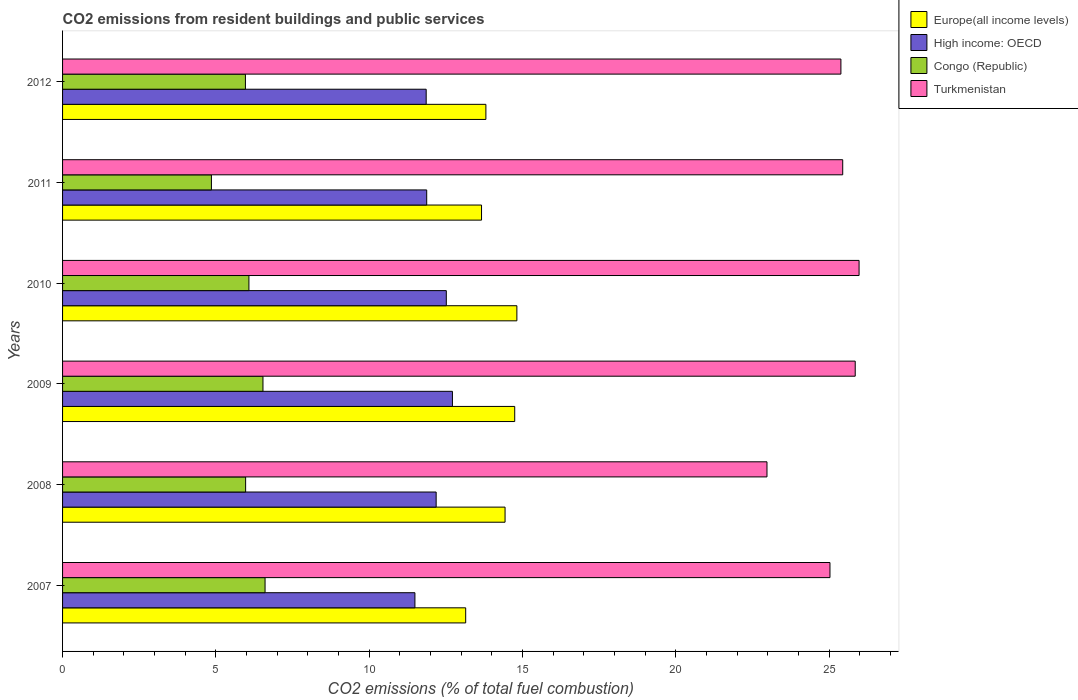How many bars are there on the 2nd tick from the top?
Your answer should be compact. 4. How many bars are there on the 2nd tick from the bottom?
Provide a succinct answer. 4. What is the total CO2 emitted in Turkmenistan in 2008?
Your answer should be very brief. 22.97. Across all years, what is the maximum total CO2 emitted in High income: OECD?
Your answer should be very brief. 12.71. Across all years, what is the minimum total CO2 emitted in Turkmenistan?
Make the answer very short. 22.97. In which year was the total CO2 emitted in Turkmenistan maximum?
Provide a short and direct response. 2010. What is the total total CO2 emitted in Congo (Republic) in the graph?
Offer a very short reply. 36. What is the difference between the total CO2 emitted in High income: OECD in 2011 and that in 2012?
Your answer should be compact. 0.02. What is the difference between the total CO2 emitted in Europe(all income levels) in 2010 and the total CO2 emitted in High income: OECD in 2009?
Your answer should be very brief. 2.1. What is the average total CO2 emitted in Turkmenistan per year?
Your answer should be very brief. 25.11. In the year 2011, what is the difference between the total CO2 emitted in Europe(all income levels) and total CO2 emitted in Turkmenistan?
Give a very brief answer. -11.78. In how many years, is the total CO2 emitted in Europe(all income levels) greater than 1 ?
Make the answer very short. 6. What is the ratio of the total CO2 emitted in Turkmenistan in 2007 to that in 2009?
Your response must be concise. 0.97. Is the difference between the total CO2 emitted in Europe(all income levels) in 2008 and 2009 greater than the difference between the total CO2 emitted in Turkmenistan in 2008 and 2009?
Give a very brief answer. Yes. What is the difference between the highest and the second highest total CO2 emitted in Congo (Republic)?
Ensure brevity in your answer.  0.07. What is the difference between the highest and the lowest total CO2 emitted in Turkmenistan?
Ensure brevity in your answer.  3. Is the sum of the total CO2 emitted in Turkmenistan in 2009 and 2011 greater than the maximum total CO2 emitted in Europe(all income levels) across all years?
Your answer should be compact. Yes. What does the 3rd bar from the top in 2007 represents?
Provide a succinct answer. High income: OECD. What does the 1st bar from the bottom in 2009 represents?
Offer a very short reply. Europe(all income levels). Are the values on the major ticks of X-axis written in scientific E-notation?
Provide a short and direct response. No. Does the graph contain any zero values?
Your answer should be compact. No. Does the graph contain grids?
Your answer should be very brief. No. How are the legend labels stacked?
Offer a terse response. Vertical. What is the title of the graph?
Give a very brief answer. CO2 emissions from resident buildings and public services. Does "Heavily indebted poor countries" appear as one of the legend labels in the graph?
Give a very brief answer. No. What is the label or title of the X-axis?
Your answer should be compact. CO2 emissions (% of total fuel combustion). What is the label or title of the Y-axis?
Your response must be concise. Years. What is the CO2 emissions (% of total fuel combustion) in Europe(all income levels) in 2007?
Give a very brief answer. 13.15. What is the CO2 emissions (% of total fuel combustion) of High income: OECD in 2007?
Make the answer very short. 11.49. What is the CO2 emissions (% of total fuel combustion) in Congo (Republic) in 2007?
Provide a succinct answer. 6.6. What is the CO2 emissions (% of total fuel combustion) of Turkmenistan in 2007?
Make the answer very short. 25.03. What is the CO2 emissions (% of total fuel combustion) of Europe(all income levels) in 2008?
Your answer should be very brief. 14.43. What is the CO2 emissions (% of total fuel combustion) in High income: OECD in 2008?
Your answer should be very brief. 12.18. What is the CO2 emissions (% of total fuel combustion) in Congo (Republic) in 2008?
Provide a short and direct response. 5.97. What is the CO2 emissions (% of total fuel combustion) of Turkmenistan in 2008?
Offer a very short reply. 22.97. What is the CO2 emissions (% of total fuel combustion) of Europe(all income levels) in 2009?
Make the answer very short. 14.75. What is the CO2 emissions (% of total fuel combustion) in High income: OECD in 2009?
Offer a very short reply. 12.71. What is the CO2 emissions (% of total fuel combustion) of Congo (Republic) in 2009?
Keep it short and to the point. 6.54. What is the CO2 emissions (% of total fuel combustion) in Turkmenistan in 2009?
Your response must be concise. 25.85. What is the CO2 emissions (% of total fuel combustion) of Europe(all income levels) in 2010?
Keep it short and to the point. 14.82. What is the CO2 emissions (% of total fuel combustion) in High income: OECD in 2010?
Your response must be concise. 12.51. What is the CO2 emissions (% of total fuel combustion) of Congo (Republic) in 2010?
Provide a short and direct response. 6.08. What is the CO2 emissions (% of total fuel combustion) in Turkmenistan in 2010?
Give a very brief answer. 25.98. What is the CO2 emissions (% of total fuel combustion) in Europe(all income levels) in 2011?
Your answer should be very brief. 13.66. What is the CO2 emissions (% of total fuel combustion) in High income: OECD in 2011?
Ensure brevity in your answer.  11.88. What is the CO2 emissions (% of total fuel combustion) in Congo (Republic) in 2011?
Ensure brevity in your answer.  4.85. What is the CO2 emissions (% of total fuel combustion) in Turkmenistan in 2011?
Provide a short and direct response. 25.44. What is the CO2 emissions (% of total fuel combustion) in Europe(all income levels) in 2012?
Provide a succinct answer. 13.81. What is the CO2 emissions (% of total fuel combustion) in High income: OECD in 2012?
Offer a terse response. 11.86. What is the CO2 emissions (% of total fuel combustion) in Congo (Republic) in 2012?
Your answer should be very brief. 5.96. What is the CO2 emissions (% of total fuel combustion) of Turkmenistan in 2012?
Provide a short and direct response. 25.38. Across all years, what is the maximum CO2 emissions (% of total fuel combustion) in Europe(all income levels)?
Your answer should be compact. 14.82. Across all years, what is the maximum CO2 emissions (% of total fuel combustion) in High income: OECD?
Make the answer very short. 12.71. Across all years, what is the maximum CO2 emissions (% of total fuel combustion) of Congo (Republic)?
Your response must be concise. 6.6. Across all years, what is the maximum CO2 emissions (% of total fuel combustion) of Turkmenistan?
Keep it short and to the point. 25.98. Across all years, what is the minimum CO2 emissions (% of total fuel combustion) in Europe(all income levels)?
Keep it short and to the point. 13.15. Across all years, what is the minimum CO2 emissions (% of total fuel combustion) in High income: OECD?
Make the answer very short. 11.49. Across all years, what is the minimum CO2 emissions (% of total fuel combustion) of Congo (Republic)?
Provide a short and direct response. 4.85. Across all years, what is the minimum CO2 emissions (% of total fuel combustion) of Turkmenistan?
Your response must be concise. 22.97. What is the total CO2 emissions (% of total fuel combustion) in Europe(all income levels) in the graph?
Offer a terse response. 84.61. What is the total CO2 emissions (% of total fuel combustion) in High income: OECD in the graph?
Offer a very short reply. 72.64. What is the total CO2 emissions (% of total fuel combustion) in Congo (Republic) in the graph?
Provide a short and direct response. 36. What is the total CO2 emissions (% of total fuel combustion) in Turkmenistan in the graph?
Offer a terse response. 150.65. What is the difference between the CO2 emissions (% of total fuel combustion) in Europe(all income levels) in 2007 and that in 2008?
Offer a very short reply. -1.28. What is the difference between the CO2 emissions (% of total fuel combustion) in High income: OECD in 2007 and that in 2008?
Your response must be concise. -0.69. What is the difference between the CO2 emissions (% of total fuel combustion) in Congo (Republic) in 2007 and that in 2008?
Your answer should be very brief. 0.63. What is the difference between the CO2 emissions (% of total fuel combustion) of Turkmenistan in 2007 and that in 2008?
Ensure brevity in your answer.  2.05. What is the difference between the CO2 emissions (% of total fuel combustion) of Europe(all income levels) in 2007 and that in 2009?
Your answer should be very brief. -1.6. What is the difference between the CO2 emissions (% of total fuel combustion) in High income: OECD in 2007 and that in 2009?
Offer a very short reply. -1.22. What is the difference between the CO2 emissions (% of total fuel combustion) of Congo (Republic) in 2007 and that in 2009?
Make the answer very short. 0.07. What is the difference between the CO2 emissions (% of total fuel combustion) in Turkmenistan in 2007 and that in 2009?
Offer a very short reply. -0.82. What is the difference between the CO2 emissions (% of total fuel combustion) in Europe(all income levels) in 2007 and that in 2010?
Offer a very short reply. -1.67. What is the difference between the CO2 emissions (% of total fuel combustion) of High income: OECD in 2007 and that in 2010?
Keep it short and to the point. -1.02. What is the difference between the CO2 emissions (% of total fuel combustion) in Congo (Republic) in 2007 and that in 2010?
Make the answer very short. 0.53. What is the difference between the CO2 emissions (% of total fuel combustion) in Turkmenistan in 2007 and that in 2010?
Ensure brevity in your answer.  -0.95. What is the difference between the CO2 emissions (% of total fuel combustion) of Europe(all income levels) in 2007 and that in 2011?
Your answer should be very brief. -0.52. What is the difference between the CO2 emissions (% of total fuel combustion) in High income: OECD in 2007 and that in 2011?
Give a very brief answer. -0.38. What is the difference between the CO2 emissions (% of total fuel combustion) of Congo (Republic) in 2007 and that in 2011?
Your response must be concise. 1.75. What is the difference between the CO2 emissions (% of total fuel combustion) in Turkmenistan in 2007 and that in 2011?
Keep it short and to the point. -0.42. What is the difference between the CO2 emissions (% of total fuel combustion) of Europe(all income levels) in 2007 and that in 2012?
Make the answer very short. -0.66. What is the difference between the CO2 emissions (% of total fuel combustion) of High income: OECD in 2007 and that in 2012?
Make the answer very short. -0.37. What is the difference between the CO2 emissions (% of total fuel combustion) of Congo (Republic) in 2007 and that in 2012?
Offer a very short reply. 0.64. What is the difference between the CO2 emissions (% of total fuel combustion) in Turkmenistan in 2007 and that in 2012?
Your answer should be very brief. -0.36. What is the difference between the CO2 emissions (% of total fuel combustion) of Europe(all income levels) in 2008 and that in 2009?
Keep it short and to the point. -0.32. What is the difference between the CO2 emissions (% of total fuel combustion) in High income: OECD in 2008 and that in 2009?
Offer a very short reply. -0.53. What is the difference between the CO2 emissions (% of total fuel combustion) in Congo (Republic) in 2008 and that in 2009?
Your answer should be very brief. -0.57. What is the difference between the CO2 emissions (% of total fuel combustion) of Turkmenistan in 2008 and that in 2009?
Offer a terse response. -2.88. What is the difference between the CO2 emissions (% of total fuel combustion) of Europe(all income levels) in 2008 and that in 2010?
Keep it short and to the point. -0.39. What is the difference between the CO2 emissions (% of total fuel combustion) of High income: OECD in 2008 and that in 2010?
Your response must be concise. -0.33. What is the difference between the CO2 emissions (% of total fuel combustion) of Congo (Republic) in 2008 and that in 2010?
Offer a terse response. -0.11. What is the difference between the CO2 emissions (% of total fuel combustion) of Turkmenistan in 2008 and that in 2010?
Offer a terse response. -3. What is the difference between the CO2 emissions (% of total fuel combustion) in Europe(all income levels) in 2008 and that in 2011?
Your answer should be compact. 0.77. What is the difference between the CO2 emissions (% of total fuel combustion) in High income: OECD in 2008 and that in 2011?
Your answer should be compact. 0.31. What is the difference between the CO2 emissions (% of total fuel combustion) of Congo (Republic) in 2008 and that in 2011?
Your answer should be compact. 1.12. What is the difference between the CO2 emissions (% of total fuel combustion) of Turkmenistan in 2008 and that in 2011?
Offer a very short reply. -2.47. What is the difference between the CO2 emissions (% of total fuel combustion) in Europe(all income levels) in 2008 and that in 2012?
Offer a terse response. 0.63. What is the difference between the CO2 emissions (% of total fuel combustion) of High income: OECD in 2008 and that in 2012?
Make the answer very short. 0.33. What is the difference between the CO2 emissions (% of total fuel combustion) of Congo (Republic) in 2008 and that in 2012?
Your answer should be compact. 0.01. What is the difference between the CO2 emissions (% of total fuel combustion) in Turkmenistan in 2008 and that in 2012?
Give a very brief answer. -2.41. What is the difference between the CO2 emissions (% of total fuel combustion) in Europe(all income levels) in 2009 and that in 2010?
Give a very brief answer. -0.07. What is the difference between the CO2 emissions (% of total fuel combustion) in High income: OECD in 2009 and that in 2010?
Your response must be concise. 0.2. What is the difference between the CO2 emissions (% of total fuel combustion) in Congo (Republic) in 2009 and that in 2010?
Make the answer very short. 0.46. What is the difference between the CO2 emissions (% of total fuel combustion) of Turkmenistan in 2009 and that in 2010?
Offer a very short reply. -0.13. What is the difference between the CO2 emissions (% of total fuel combustion) in Europe(all income levels) in 2009 and that in 2011?
Make the answer very short. 1.08. What is the difference between the CO2 emissions (% of total fuel combustion) in High income: OECD in 2009 and that in 2011?
Provide a succinct answer. 0.84. What is the difference between the CO2 emissions (% of total fuel combustion) of Congo (Republic) in 2009 and that in 2011?
Keep it short and to the point. 1.68. What is the difference between the CO2 emissions (% of total fuel combustion) of Turkmenistan in 2009 and that in 2011?
Provide a succinct answer. 0.41. What is the difference between the CO2 emissions (% of total fuel combustion) of Europe(all income levels) in 2009 and that in 2012?
Keep it short and to the point. 0.94. What is the difference between the CO2 emissions (% of total fuel combustion) of High income: OECD in 2009 and that in 2012?
Your answer should be compact. 0.86. What is the difference between the CO2 emissions (% of total fuel combustion) of Congo (Republic) in 2009 and that in 2012?
Provide a succinct answer. 0.57. What is the difference between the CO2 emissions (% of total fuel combustion) in Turkmenistan in 2009 and that in 2012?
Make the answer very short. 0.47. What is the difference between the CO2 emissions (% of total fuel combustion) in Europe(all income levels) in 2010 and that in 2011?
Your response must be concise. 1.15. What is the difference between the CO2 emissions (% of total fuel combustion) in High income: OECD in 2010 and that in 2011?
Give a very brief answer. 0.64. What is the difference between the CO2 emissions (% of total fuel combustion) in Congo (Republic) in 2010 and that in 2011?
Give a very brief answer. 1.22. What is the difference between the CO2 emissions (% of total fuel combustion) in Turkmenistan in 2010 and that in 2011?
Provide a short and direct response. 0.53. What is the difference between the CO2 emissions (% of total fuel combustion) of Europe(all income levels) in 2010 and that in 2012?
Make the answer very short. 1.01. What is the difference between the CO2 emissions (% of total fuel combustion) of High income: OECD in 2010 and that in 2012?
Give a very brief answer. 0.66. What is the difference between the CO2 emissions (% of total fuel combustion) in Congo (Republic) in 2010 and that in 2012?
Your answer should be very brief. 0.11. What is the difference between the CO2 emissions (% of total fuel combustion) in Turkmenistan in 2010 and that in 2012?
Keep it short and to the point. 0.59. What is the difference between the CO2 emissions (% of total fuel combustion) of Europe(all income levels) in 2011 and that in 2012?
Ensure brevity in your answer.  -0.14. What is the difference between the CO2 emissions (% of total fuel combustion) in High income: OECD in 2011 and that in 2012?
Make the answer very short. 0.02. What is the difference between the CO2 emissions (% of total fuel combustion) of Congo (Republic) in 2011 and that in 2012?
Offer a very short reply. -1.11. What is the difference between the CO2 emissions (% of total fuel combustion) of Turkmenistan in 2011 and that in 2012?
Offer a terse response. 0.06. What is the difference between the CO2 emissions (% of total fuel combustion) of Europe(all income levels) in 2007 and the CO2 emissions (% of total fuel combustion) of High income: OECD in 2008?
Give a very brief answer. 0.96. What is the difference between the CO2 emissions (% of total fuel combustion) of Europe(all income levels) in 2007 and the CO2 emissions (% of total fuel combustion) of Congo (Republic) in 2008?
Offer a very short reply. 7.18. What is the difference between the CO2 emissions (% of total fuel combustion) of Europe(all income levels) in 2007 and the CO2 emissions (% of total fuel combustion) of Turkmenistan in 2008?
Provide a short and direct response. -9.83. What is the difference between the CO2 emissions (% of total fuel combustion) of High income: OECD in 2007 and the CO2 emissions (% of total fuel combustion) of Congo (Republic) in 2008?
Ensure brevity in your answer.  5.52. What is the difference between the CO2 emissions (% of total fuel combustion) of High income: OECD in 2007 and the CO2 emissions (% of total fuel combustion) of Turkmenistan in 2008?
Provide a short and direct response. -11.48. What is the difference between the CO2 emissions (% of total fuel combustion) in Congo (Republic) in 2007 and the CO2 emissions (% of total fuel combustion) in Turkmenistan in 2008?
Keep it short and to the point. -16.37. What is the difference between the CO2 emissions (% of total fuel combustion) of Europe(all income levels) in 2007 and the CO2 emissions (% of total fuel combustion) of High income: OECD in 2009?
Give a very brief answer. 0.43. What is the difference between the CO2 emissions (% of total fuel combustion) in Europe(all income levels) in 2007 and the CO2 emissions (% of total fuel combustion) in Congo (Republic) in 2009?
Offer a very short reply. 6.61. What is the difference between the CO2 emissions (% of total fuel combustion) in Europe(all income levels) in 2007 and the CO2 emissions (% of total fuel combustion) in Turkmenistan in 2009?
Make the answer very short. -12.7. What is the difference between the CO2 emissions (% of total fuel combustion) in High income: OECD in 2007 and the CO2 emissions (% of total fuel combustion) in Congo (Republic) in 2009?
Make the answer very short. 4.96. What is the difference between the CO2 emissions (% of total fuel combustion) of High income: OECD in 2007 and the CO2 emissions (% of total fuel combustion) of Turkmenistan in 2009?
Your answer should be very brief. -14.36. What is the difference between the CO2 emissions (% of total fuel combustion) in Congo (Republic) in 2007 and the CO2 emissions (% of total fuel combustion) in Turkmenistan in 2009?
Keep it short and to the point. -19.25. What is the difference between the CO2 emissions (% of total fuel combustion) of Europe(all income levels) in 2007 and the CO2 emissions (% of total fuel combustion) of High income: OECD in 2010?
Provide a succinct answer. 0.63. What is the difference between the CO2 emissions (% of total fuel combustion) in Europe(all income levels) in 2007 and the CO2 emissions (% of total fuel combustion) in Congo (Republic) in 2010?
Keep it short and to the point. 7.07. What is the difference between the CO2 emissions (% of total fuel combustion) in Europe(all income levels) in 2007 and the CO2 emissions (% of total fuel combustion) in Turkmenistan in 2010?
Offer a very short reply. -12.83. What is the difference between the CO2 emissions (% of total fuel combustion) in High income: OECD in 2007 and the CO2 emissions (% of total fuel combustion) in Congo (Republic) in 2010?
Your response must be concise. 5.41. What is the difference between the CO2 emissions (% of total fuel combustion) in High income: OECD in 2007 and the CO2 emissions (% of total fuel combustion) in Turkmenistan in 2010?
Make the answer very short. -14.49. What is the difference between the CO2 emissions (% of total fuel combustion) of Congo (Republic) in 2007 and the CO2 emissions (% of total fuel combustion) of Turkmenistan in 2010?
Offer a very short reply. -19.37. What is the difference between the CO2 emissions (% of total fuel combustion) in Europe(all income levels) in 2007 and the CO2 emissions (% of total fuel combustion) in High income: OECD in 2011?
Keep it short and to the point. 1.27. What is the difference between the CO2 emissions (% of total fuel combustion) of Europe(all income levels) in 2007 and the CO2 emissions (% of total fuel combustion) of Congo (Republic) in 2011?
Offer a very short reply. 8.29. What is the difference between the CO2 emissions (% of total fuel combustion) in Europe(all income levels) in 2007 and the CO2 emissions (% of total fuel combustion) in Turkmenistan in 2011?
Provide a short and direct response. -12.3. What is the difference between the CO2 emissions (% of total fuel combustion) of High income: OECD in 2007 and the CO2 emissions (% of total fuel combustion) of Congo (Republic) in 2011?
Make the answer very short. 6.64. What is the difference between the CO2 emissions (% of total fuel combustion) of High income: OECD in 2007 and the CO2 emissions (% of total fuel combustion) of Turkmenistan in 2011?
Offer a terse response. -13.95. What is the difference between the CO2 emissions (% of total fuel combustion) in Congo (Republic) in 2007 and the CO2 emissions (% of total fuel combustion) in Turkmenistan in 2011?
Make the answer very short. -18.84. What is the difference between the CO2 emissions (% of total fuel combustion) of Europe(all income levels) in 2007 and the CO2 emissions (% of total fuel combustion) of High income: OECD in 2012?
Offer a very short reply. 1.29. What is the difference between the CO2 emissions (% of total fuel combustion) of Europe(all income levels) in 2007 and the CO2 emissions (% of total fuel combustion) of Congo (Republic) in 2012?
Offer a very short reply. 7.18. What is the difference between the CO2 emissions (% of total fuel combustion) of Europe(all income levels) in 2007 and the CO2 emissions (% of total fuel combustion) of Turkmenistan in 2012?
Give a very brief answer. -12.24. What is the difference between the CO2 emissions (% of total fuel combustion) in High income: OECD in 2007 and the CO2 emissions (% of total fuel combustion) in Congo (Republic) in 2012?
Offer a very short reply. 5.53. What is the difference between the CO2 emissions (% of total fuel combustion) of High income: OECD in 2007 and the CO2 emissions (% of total fuel combustion) of Turkmenistan in 2012?
Provide a short and direct response. -13.89. What is the difference between the CO2 emissions (% of total fuel combustion) in Congo (Republic) in 2007 and the CO2 emissions (% of total fuel combustion) in Turkmenistan in 2012?
Keep it short and to the point. -18.78. What is the difference between the CO2 emissions (% of total fuel combustion) of Europe(all income levels) in 2008 and the CO2 emissions (% of total fuel combustion) of High income: OECD in 2009?
Offer a very short reply. 1.72. What is the difference between the CO2 emissions (% of total fuel combustion) of Europe(all income levels) in 2008 and the CO2 emissions (% of total fuel combustion) of Congo (Republic) in 2009?
Provide a succinct answer. 7.89. What is the difference between the CO2 emissions (% of total fuel combustion) in Europe(all income levels) in 2008 and the CO2 emissions (% of total fuel combustion) in Turkmenistan in 2009?
Make the answer very short. -11.42. What is the difference between the CO2 emissions (% of total fuel combustion) of High income: OECD in 2008 and the CO2 emissions (% of total fuel combustion) of Congo (Republic) in 2009?
Your answer should be very brief. 5.65. What is the difference between the CO2 emissions (% of total fuel combustion) in High income: OECD in 2008 and the CO2 emissions (% of total fuel combustion) in Turkmenistan in 2009?
Ensure brevity in your answer.  -13.67. What is the difference between the CO2 emissions (% of total fuel combustion) of Congo (Republic) in 2008 and the CO2 emissions (% of total fuel combustion) of Turkmenistan in 2009?
Your answer should be very brief. -19.88. What is the difference between the CO2 emissions (% of total fuel combustion) in Europe(all income levels) in 2008 and the CO2 emissions (% of total fuel combustion) in High income: OECD in 2010?
Offer a very short reply. 1.92. What is the difference between the CO2 emissions (% of total fuel combustion) of Europe(all income levels) in 2008 and the CO2 emissions (% of total fuel combustion) of Congo (Republic) in 2010?
Provide a succinct answer. 8.35. What is the difference between the CO2 emissions (% of total fuel combustion) in Europe(all income levels) in 2008 and the CO2 emissions (% of total fuel combustion) in Turkmenistan in 2010?
Offer a terse response. -11.55. What is the difference between the CO2 emissions (% of total fuel combustion) of High income: OECD in 2008 and the CO2 emissions (% of total fuel combustion) of Congo (Republic) in 2010?
Keep it short and to the point. 6.11. What is the difference between the CO2 emissions (% of total fuel combustion) of High income: OECD in 2008 and the CO2 emissions (% of total fuel combustion) of Turkmenistan in 2010?
Offer a very short reply. -13.79. What is the difference between the CO2 emissions (% of total fuel combustion) in Congo (Republic) in 2008 and the CO2 emissions (% of total fuel combustion) in Turkmenistan in 2010?
Keep it short and to the point. -20.01. What is the difference between the CO2 emissions (% of total fuel combustion) of Europe(all income levels) in 2008 and the CO2 emissions (% of total fuel combustion) of High income: OECD in 2011?
Provide a succinct answer. 2.56. What is the difference between the CO2 emissions (% of total fuel combustion) of Europe(all income levels) in 2008 and the CO2 emissions (% of total fuel combustion) of Congo (Republic) in 2011?
Ensure brevity in your answer.  9.58. What is the difference between the CO2 emissions (% of total fuel combustion) of Europe(all income levels) in 2008 and the CO2 emissions (% of total fuel combustion) of Turkmenistan in 2011?
Provide a short and direct response. -11.01. What is the difference between the CO2 emissions (% of total fuel combustion) in High income: OECD in 2008 and the CO2 emissions (% of total fuel combustion) in Congo (Republic) in 2011?
Provide a succinct answer. 7.33. What is the difference between the CO2 emissions (% of total fuel combustion) of High income: OECD in 2008 and the CO2 emissions (% of total fuel combustion) of Turkmenistan in 2011?
Ensure brevity in your answer.  -13.26. What is the difference between the CO2 emissions (% of total fuel combustion) of Congo (Republic) in 2008 and the CO2 emissions (% of total fuel combustion) of Turkmenistan in 2011?
Give a very brief answer. -19.47. What is the difference between the CO2 emissions (% of total fuel combustion) of Europe(all income levels) in 2008 and the CO2 emissions (% of total fuel combustion) of High income: OECD in 2012?
Offer a very short reply. 2.57. What is the difference between the CO2 emissions (% of total fuel combustion) in Europe(all income levels) in 2008 and the CO2 emissions (% of total fuel combustion) in Congo (Republic) in 2012?
Provide a succinct answer. 8.47. What is the difference between the CO2 emissions (% of total fuel combustion) of Europe(all income levels) in 2008 and the CO2 emissions (% of total fuel combustion) of Turkmenistan in 2012?
Keep it short and to the point. -10.95. What is the difference between the CO2 emissions (% of total fuel combustion) in High income: OECD in 2008 and the CO2 emissions (% of total fuel combustion) in Congo (Republic) in 2012?
Your response must be concise. 6.22. What is the difference between the CO2 emissions (% of total fuel combustion) of High income: OECD in 2008 and the CO2 emissions (% of total fuel combustion) of Turkmenistan in 2012?
Ensure brevity in your answer.  -13.2. What is the difference between the CO2 emissions (% of total fuel combustion) in Congo (Republic) in 2008 and the CO2 emissions (% of total fuel combustion) in Turkmenistan in 2012?
Your response must be concise. -19.41. What is the difference between the CO2 emissions (% of total fuel combustion) of Europe(all income levels) in 2009 and the CO2 emissions (% of total fuel combustion) of High income: OECD in 2010?
Offer a very short reply. 2.23. What is the difference between the CO2 emissions (% of total fuel combustion) of Europe(all income levels) in 2009 and the CO2 emissions (% of total fuel combustion) of Congo (Republic) in 2010?
Your answer should be compact. 8.67. What is the difference between the CO2 emissions (% of total fuel combustion) in Europe(all income levels) in 2009 and the CO2 emissions (% of total fuel combustion) in Turkmenistan in 2010?
Your response must be concise. -11.23. What is the difference between the CO2 emissions (% of total fuel combustion) in High income: OECD in 2009 and the CO2 emissions (% of total fuel combustion) in Congo (Republic) in 2010?
Your response must be concise. 6.64. What is the difference between the CO2 emissions (% of total fuel combustion) of High income: OECD in 2009 and the CO2 emissions (% of total fuel combustion) of Turkmenistan in 2010?
Provide a succinct answer. -13.26. What is the difference between the CO2 emissions (% of total fuel combustion) of Congo (Republic) in 2009 and the CO2 emissions (% of total fuel combustion) of Turkmenistan in 2010?
Provide a succinct answer. -19.44. What is the difference between the CO2 emissions (% of total fuel combustion) of Europe(all income levels) in 2009 and the CO2 emissions (% of total fuel combustion) of High income: OECD in 2011?
Keep it short and to the point. 2.87. What is the difference between the CO2 emissions (% of total fuel combustion) in Europe(all income levels) in 2009 and the CO2 emissions (% of total fuel combustion) in Congo (Republic) in 2011?
Provide a short and direct response. 9.89. What is the difference between the CO2 emissions (% of total fuel combustion) in Europe(all income levels) in 2009 and the CO2 emissions (% of total fuel combustion) in Turkmenistan in 2011?
Keep it short and to the point. -10.7. What is the difference between the CO2 emissions (% of total fuel combustion) of High income: OECD in 2009 and the CO2 emissions (% of total fuel combustion) of Congo (Republic) in 2011?
Your answer should be very brief. 7.86. What is the difference between the CO2 emissions (% of total fuel combustion) of High income: OECD in 2009 and the CO2 emissions (% of total fuel combustion) of Turkmenistan in 2011?
Provide a short and direct response. -12.73. What is the difference between the CO2 emissions (% of total fuel combustion) in Congo (Republic) in 2009 and the CO2 emissions (% of total fuel combustion) in Turkmenistan in 2011?
Your answer should be very brief. -18.91. What is the difference between the CO2 emissions (% of total fuel combustion) of Europe(all income levels) in 2009 and the CO2 emissions (% of total fuel combustion) of High income: OECD in 2012?
Offer a terse response. 2.89. What is the difference between the CO2 emissions (% of total fuel combustion) in Europe(all income levels) in 2009 and the CO2 emissions (% of total fuel combustion) in Congo (Republic) in 2012?
Give a very brief answer. 8.78. What is the difference between the CO2 emissions (% of total fuel combustion) in Europe(all income levels) in 2009 and the CO2 emissions (% of total fuel combustion) in Turkmenistan in 2012?
Give a very brief answer. -10.64. What is the difference between the CO2 emissions (% of total fuel combustion) in High income: OECD in 2009 and the CO2 emissions (% of total fuel combustion) in Congo (Republic) in 2012?
Offer a very short reply. 6.75. What is the difference between the CO2 emissions (% of total fuel combustion) in High income: OECD in 2009 and the CO2 emissions (% of total fuel combustion) in Turkmenistan in 2012?
Give a very brief answer. -12.67. What is the difference between the CO2 emissions (% of total fuel combustion) in Congo (Republic) in 2009 and the CO2 emissions (% of total fuel combustion) in Turkmenistan in 2012?
Give a very brief answer. -18.85. What is the difference between the CO2 emissions (% of total fuel combustion) in Europe(all income levels) in 2010 and the CO2 emissions (% of total fuel combustion) in High income: OECD in 2011?
Give a very brief answer. 2.94. What is the difference between the CO2 emissions (% of total fuel combustion) of Europe(all income levels) in 2010 and the CO2 emissions (% of total fuel combustion) of Congo (Republic) in 2011?
Offer a very short reply. 9.96. What is the difference between the CO2 emissions (% of total fuel combustion) of Europe(all income levels) in 2010 and the CO2 emissions (% of total fuel combustion) of Turkmenistan in 2011?
Offer a very short reply. -10.63. What is the difference between the CO2 emissions (% of total fuel combustion) in High income: OECD in 2010 and the CO2 emissions (% of total fuel combustion) in Congo (Republic) in 2011?
Make the answer very short. 7.66. What is the difference between the CO2 emissions (% of total fuel combustion) of High income: OECD in 2010 and the CO2 emissions (% of total fuel combustion) of Turkmenistan in 2011?
Make the answer very short. -12.93. What is the difference between the CO2 emissions (% of total fuel combustion) of Congo (Republic) in 2010 and the CO2 emissions (% of total fuel combustion) of Turkmenistan in 2011?
Your response must be concise. -19.37. What is the difference between the CO2 emissions (% of total fuel combustion) in Europe(all income levels) in 2010 and the CO2 emissions (% of total fuel combustion) in High income: OECD in 2012?
Provide a short and direct response. 2.96. What is the difference between the CO2 emissions (% of total fuel combustion) in Europe(all income levels) in 2010 and the CO2 emissions (% of total fuel combustion) in Congo (Republic) in 2012?
Your response must be concise. 8.85. What is the difference between the CO2 emissions (% of total fuel combustion) in Europe(all income levels) in 2010 and the CO2 emissions (% of total fuel combustion) in Turkmenistan in 2012?
Your response must be concise. -10.57. What is the difference between the CO2 emissions (% of total fuel combustion) in High income: OECD in 2010 and the CO2 emissions (% of total fuel combustion) in Congo (Republic) in 2012?
Provide a short and direct response. 6.55. What is the difference between the CO2 emissions (% of total fuel combustion) in High income: OECD in 2010 and the CO2 emissions (% of total fuel combustion) in Turkmenistan in 2012?
Your answer should be very brief. -12.87. What is the difference between the CO2 emissions (% of total fuel combustion) in Congo (Republic) in 2010 and the CO2 emissions (% of total fuel combustion) in Turkmenistan in 2012?
Your answer should be compact. -19.31. What is the difference between the CO2 emissions (% of total fuel combustion) in Europe(all income levels) in 2011 and the CO2 emissions (% of total fuel combustion) in High income: OECD in 2012?
Offer a very short reply. 1.8. What is the difference between the CO2 emissions (% of total fuel combustion) in Europe(all income levels) in 2011 and the CO2 emissions (% of total fuel combustion) in Congo (Republic) in 2012?
Provide a short and direct response. 7.7. What is the difference between the CO2 emissions (% of total fuel combustion) of Europe(all income levels) in 2011 and the CO2 emissions (% of total fuel combustion) of Turkmenistan in 2012?
Your answer should be compact. -11.72. What is the difference between the CO2 emissions (% of total fuel combustion) of High income: OECD in 2011 and the CO2 emissions (% of total fuel combustion) of Congo (Republic) in 2012?
Keep it short and to the point. 5.91. What is the difference between the CO2 emissions (% of total fuel combustion) of High income: OECD in 2011 and the CO2 emissions (% of total fuel combustion) of Turkmenistan in 2012?
Provide a short and direct response. -13.51. What is the difference between the CO2 emissions (% of total fuel combustion) in Congo (Republic) in 2011 and the CO2 emissions (% of total fuel combustion) in Turkmenistan in 2012?
Your answer should be very brief. -20.53. What is the average CO2 emissions (% of total fuel combustion) of Europe(all income levels) per year?
Offer a terse response. 14.1. What is the average CO2 emissions (% of total fuel combustion) in High income: OECD per year?
Your answer should be very brief. 12.11. What is the average CO2 emissions (% of total fuel combustion) of Congo (Republic) per year?
Provide a succinct answer. 6. What is the average CO2 emissions (% of total fuel combustion) of Turkmenistan per year?
Provide a short and direct response. 25.11. In the year 2007, what is the difference between the CO2 emissions (% of total fuel combustion) of Europe(all income levels) and CO2 emissions (% of total fuel combustion) of High income: OECD?
Provide a succinct answer. 1.66. In the year 2007, what is the difference between the CO2 emissions (% of total fuel combustion) in Europe(all income levels) and CO2 emissions (% of total fuel combustion) in Congo (Republic)?
Offer a very short reply. 6.54. In the year 2007, what is the difference between the CO2 emissions (% of total fuel combustion) in Europe(all income levels) and CO2 emissions (% of total fuel combustion) in Turkmenistan?
Your answer should be very brief. -11.88. In the year 2007, what is the difference between the CO2 emissions (% of total fuel combustion) in High income: OECD and CO2 emissions (% of total fuel combustion) in Congo (Republic)?
Provide a succinct answer. 4.89. In the year 2007, what is the difference between the CO2 emissions (% of total fuel combustion) of High income: OECD and CO2 emissions (% of total fuel combustion) of Turkmenistan?
Your response must be concise. -13.54. In the year 2007, what is the difference between the CO2 emissions (% of total fuel combustion) in Congo (Republic) and CO2 emissions (% of total fuel combustion) in Turkmenistan?
Ensure brevity in your answer.  -18.42. In the year 2008, what is the difference between the CO2 emissions (% of total fuel combustion) of Europe(all income levels) and CO2 emissions (% of total fuel combustion) of High income: OECD?
Ensure brevity in your answer.  2.25. In the year 2008, what is the difference between the CO2 emissions (% of total fuel combustion) of Europe(all income levels) and CO2 emissions (% of total fuel combustion) of Congo (Republic)?
Ensure brevity in your answer.  8.46. In the year 2008, what is the difference between the CO2 emissions (% of total fuel combustion) of Europe(all income levels) and CO2 emissions (% of total fuel combustion) of Turkmenistan?
Ensure brevity in your answer.  -8.54. In the year 2008, what is the difference between the CO2 emissions (% of total fuel combustion) in High income: OECD and CO2 emissions (% of total fuel combustion) in Congo (Republic)?
Provide a succinct answer. 6.21. In the year 2008, what is the difference between the CO2 emissions (% of total fuel combustion) of High income: OECD and CO2 emissions (% of total fuel combustion) of Turkmenistan?
Keep it short and to the point. -10.79. In the year 2008, what is the difference between the CO2 emissions (% of total fuel combustion) in Congo (Republic) and CO2 emissions (% of total fuel combustion) in Turkmenistan?
Your answer should be very brief. -17. In the year 2009, what is the difference between the CO2 emissions (% of total fuel combustion) of Europe(all income levels) and CO2 emissions (% of total fuel combustion) of High income: OECD?
Provide a short and direct response. 2.03. In the year 2009, what is the difference between the CO2 emissions (% of total fuel combustion) in Europe(all income levels) and CO2 emissions (% of total fuel combustion) in Congo (Republic)?
Make the answer very short. 8.21. In the year 2009, what is the difference between the CO2 emissions (% of total fuel combustion) of Europe(all income levels) and CO2 emissions (% of total fuel combustion) of Turkmenistan?
Provide a short and direct response. -11.1. In the year 2009, what is the difference between the CO2 emissions (% of total fuel combustion) in High income: OECD and CO2 emissions (% of total fuel combustion) in Congo (Republic)?
Your answer should be very brief. 6.18. In the year 2009, what is the difference between the CO2 emissions (% of total fuel combustion) in High income: OECD and CO2 emissions (% of total fuel combustion) in Turkmenistan?
Offer a terse response. -13.14. In the year 2009, what is the difference between the CO2 emissions (% of total fuel combustion) of Congo (Republic) and CO2 emissions (% of total fuel combustion) of Turkmenistan?
Offer a very short reply. -19.31. In the year 2010, what is the difference between the CO2 emissions (% of total fuel combustion) in Europe(all income levels) and CO2 emissions (% of total fuel combustion) in High income: OECD?
Provide a short and direct response. 2.3. In the year 2010, what is the difference between the CO2 emissions (% of total fuel combustion) of Europe(all income levels) and CO2 emissions (% of total fuel combustion) of Congo (Republic)?
Your answer should be compact. 8.74. In the year 2010, what is the difference between the CO2 emissions (% of total fuel combustion) of Europe(all income levels) and CO2 emissions (% of total fuel combustion) of Turkmenistan?
Make the answer very short. -11.16. In the year 2010, what is the difference between the CO2 emissions (% of total fuel combustion) in High income: OECD and CO2 emissions (% of total fuel combustion) in Congo (Republic)?
Your response must be concise. 6.44. In the year 2010, what is the difference between the CO2 emissions (% of total fuel combustion) of High income: OECD and CO2 emissions (% of total fuel combustion) of Turkmenistan?
Offer a very short reply. -13.46. In the year 2010, what is the difference between the CO2 emissions (% of total fuel combustion) in Congo (Republic) and CO2 emissions (% of total fuel combustion) in Turkmenistan?
Provide a succinct answer. -19.9. In the year 2011, what is the difference between the CO2 emissions (% of total fuel combustion) of Europe(all income levels) and CO2 emissions (% of total fuel combustion) of High income: OECD?
Keep it short and to the point. 1.79. In the year 2011, what is the difference between the CO2 emissions (% of total fuel combustion) in Europe(all income levels) and CO2 emissions (% of total fuel combustion) in Congo (Republic)?
Keep it short and to the point. 8.81. In the year 2011, what is the difference between the CO2 emissions (% of total fuel combustion) of Europe(all income levels) and CO2 emissions (% of total fuel combustion) of Turkmenistan?
Your answer should be very brief. -11.78. In the year 2011, what is the difference between the CO2 emissions (% of total fuel combustion) in High income: OECD and CO2 emissions (% of total fuel combustion) in Congo (Republic)?
Provide a short and direct response. 7.02. In the year 2011, what is the difference between the CO2 emissions (% of total fuel combustion) of High income: OECD and CO2 emissions (% of total fuel combustion) of Turkmenistan?
Provide a succinct answer. -13.57. In the year 2011, what is the difference between the CO2 emissions (% of total fuel combustion) of Congo (Republic) and CO2 emissions (% of total fuel combustion) of Turkmenistan?
Give a very brief answer. -20.59. In the year 2012, what is the difference between the CO2 emissions (% of total fuel combustion) of Europe(all income levels) and CO2 emissions (% of total fuel combustion) of High income: OECD?
Offer a very short reply. 1.95. In the year 2012, what is the difference between the CO2 emissions (% of total fuel combustion) of Europe(all income levels) and CO2 emissions (% of total fuel combustion) of Congo (Republic)?
Provide a short and direct response. 7.84. In the year 2012, what is the difference between the CO2 emissions (% of total fuel combustion) in Europe(all income levels) and CO2 emissions (% of total fuel combustion) in Turkmenistan?
Provide a succinct answer. -11.58. In the year 2012, what is the difference between the CO2 emissions (% of total fuel combustion) of High income: OECD and CO2 emissions (% of total fuel combustion) of Congo (Republic)?
Ensure brevity in your answer.  5.9. In the year 2012, what is the difference between the CO2 emissions (% of total fuel combustion) in High income: OECD and CO2 emissions (% of total fuel combustion) in Turkmenistan?
Offer a terse response. -13.53. In the year 2012, what is the difference between the CO2 emissions (% of total fuel combustion) in Congo (Republic) and CO2 emissions (% of total fuel combustion) in Turkmenistan?
Keep it short and to the point. -19.42. What is the ratio of the CO2 emissions (% of total fuel combustion) of Europe(all income levels) in 2007 to that in 2008?
Your answer should be compact. 0.91. What is the ratio of the CO2 emissions (% of total fuel combustion) of High income: OECD in 2007 to that in 2008?
Your response must be concise. 0.94. What is the ratio of the CO2 emissions (% of total fuel combustion) of Congo (Republic) in 2007 to that in 2008?
Offer a very short reply. 1.11. What is the ratio of the CO2 emissions (% of total fuel combustion) of Turkmenistan in 2007 to that in 2008?
Offer a terse response. 1.09. What is the ratio of the CO2 emissions (% of total fuel combustion) of Europe(all income levels) in 2007 to that in 2009?
Provide a short and direct response. 0.89. What is the ratio of the CO2 emissions (% of total fuel combustion) of High income: OECD in 2007 to that in 2009?
Provide a short and direct response. 0.9. What is the ratio of the CO2 emissions (% of total fuel combustion) of Congo (Republic) in 2007 to that in 2009?
Give a very brief answer. 1.01. What is the ratio of the CO2 emissions (% of total fuel combustion) in Turkmenistan in 2007 to that in 2009?
Ensure brevity in your answer.  0.97. What is the ratio of the CO2 emissions (% of total fuel combustion) in Europe(all income levels) in 2007 to that in 2010?
Your response must be concise. 0.89. What is the ratio of the CO2 emissions (% of total fuel combustion) of High income: OECD in 2007 to that in 2010?
Provide a short and direct response. 0.92. What is the ratio of the CO2 emissions (% of total fuel combustion) of Congo (Republic) in 2007 to that in 2010?
Offer a terse response. 1.09. What is the ratio of the CO2 emissions (% of total fuel combustion) of Turkmenistan in 2007 to that in 2010?
Your response must be concise. 0.96. What is the ratio of the CO2 emissions (% of total fuel combustion) of Europe(all income levels) in 2007 to that in 2011?
Keep it short and to the point. 0.96. What is the ratio of the CO2 emissions (% of total fuel combustion) of High income: OECD in 2007 to that in 2011?
Offer a very short reply. 0.97. What is the ratio of the CO2 emissions (% of total fuel combustion) of Congo (Republic) in 2007 to that in 2011?
Provide a succinct answer. 1.36. What is the ratio of the CO2 emissions (% of total fuel combustion) of Turkmenistan in 2007 to that in 2011?
Provide a succinct answer. 0.98. What is the ratio of the CO2 emissions (% of total fuel combustion) in Europe(all income levels) in 2007 to that in 2012?
Offer a very short reply. 0.95. What is the ratio of the CO2 emissions (% of total fuel combustion) of High income: OECD in 2007 to that in 2012?
Your answer should be compact. 0.97. What is the ratio of the CO2 emissions (% of total fuel combustion) in Congo (Republic) in 2007 to that in 2012?
Your response must be concise. 1.11. What is the ratio of the CO2 emissions (% of total fuel combustion) of Turkmenistan in 2007 to that in 2012?
Provide a short and direct response. 0.99. What is the ratio of the CO2 emissions (% of total fuel combustion) in Europe(all income levels) in 2008 to that in 2009?
Provide a short and direct response. 0.98. What is the ratio of the CO2 emissions (% of total fuel combustion) of High income: OECD in 2008 to that in 2009?
Offer a terse response. 0.96. What is the ratio of the CO2 emissions (% of total fuel combustion) in Congo (Republic) in 2008 to that in 2009?
Your answer should be compact. 0.91. What is the ratio of the CO2 emissions (% of total fuel combustion) of Turkmenistan in 2008 to that in 2009?
Ensure brevity in your answer.  0.89. What is the ratio of the CO2 emissions (% of total fuel combustion) of Europe(all income levels) in 2008 to that in 2010?
Ensure brevity in your answer.  0.97. What is the ratio of the CO2 emissions (% of total fuel combustion) in High income: OECD in 2008 to that in 2010?
Make the answer very short. 0.97. What is the ratio of the CO2 emissions (% of total fuel combustion) in Congo (Republic) in 2008 to that in 2010?
Your answer should be very brief. 0.98. What is the ratio of the CO2 emissions (% of total fuel combustion) in Turkmenistan in 2008 to that in 2010?
Provide a succinct answer. 0.88. What is the ratio of the CO2 emissions (% of total fuel combustion) in Europe(all income levels) in 2008 to that in 2011?
Your answer should be compact. 1.06. What is the ratio of the CO2 emissions (% of total fuel combustion) in High income: OECD in 2008 to that in 2011?
Ensure brevity in your answer.  1.03. What is the ratio of the CO2 emissions (% of total fuel combustion) in Congo (Republic) in 2008 to that in 2011?
Provide a short and direct response. 1.23. What is the ratio of the CO2 emissions (% of total fuel combustion) of Turkmenistan in 2008 to that in 2011?
Keep it short and to the point. 0.9. What is the ratio of the CO2 emissions (% of total fuel combustion) in Europe(all income levels) in 2008 to that in 2012?
Make the answer very short. 1.05. What is the ratio of the CO2 emissions (% of total fuel combustion) of High income: OECD in 2008 to that in 2012?
Offer a very short reply. 1.03. What is the ratio of the CO2 emissions (% of total fuel combustion) of Congo (Republic) in 2008 to that in 2012?
Offer a terse response. 1. What is the ratio of the CO2 emissions (% of total fuel combustion) of Turkmenistan in 2008 to that in 2012?
Your answer should be compact. 0.91. What is the ratio of the CO2 emissions (% of total fuel combustion) of Europe(all income levels) in 2009 to that in 2010?
Provide a short and direct response. 1. What is the ratio of the CO2 emissions (% of total fuel combustion) of High income: OECD in 2009 to that in 2010?
Make the answer very short. 1.02. What is the ratio of the CO2 emissions (% of total fuel combustion) in Congo (Republic) in 2009 to that in 2010?
Offer a very short reply. 1.08. What is the ratio of the CO2 emissions (% of total fuel combustion) in Europe(all income levels) in 2009 to that in 2011?
Give a very brief answer. 1.08. What is the ratio of the CO2 emissions (% of total fuel combustion) of High income: OECD in 2009 to that in 2011?
Give a very brief answer. 1.07. What is the ratio of the CO2 emissions (% of total fuel combustion) of Congo (Republic) in 2009 to that in 2011?
Ensure brevity in your answer.  1.35. What is the ratio of the CO2 emissions (% of total fuel combustion) in Turkmenistan in 2009 to that in 2011?
Offer a terse response. 1.02. What is the ratio of the CO2 emissions (% of total fuel combustion) in Europe(all income levels) in 2009 to that in 2012?
Give a very brief answer. 1.07. What is the ratio of the CO2 emissions (% of total fuel combustion) in High income: OECD in 2009 to that in 2012?
Your answer should be very brief. 1.07. What is the ratio of the CO2 emissions (% of total fuel combustion) in Congo (Republic) in 2009 to that in 2012?
Ensure brevity in your answer.  1.1. What is the ratio of the CO2 emissions (% of total fuel combustion) in Turkmenistan in 2009 to that in 2012?
Ensure brevity in your answer.  1.02. What is the ratio of the CO2 emissions (% of total fuel combustion) in Europe(all income levels) in 2010 to that in 2011?
Give a very brief answer. 1.08. What is the ratio of the CO2 emissions (% of total fuel combustion) of High income: OECD in 2010 to that in 2011?
Offer a terse response. 1.05. What is the ratio of the CO2 emissions (% of total fuel combustion) of Congo (Republic) in 2010 to that in 2011?
Make the answer very short. 1.25. What is the ratio of the CO2 emissions (% of total fuel combustion) in Europe(all income levels) in 2010 to that in 2012?
Provide a short and direct response. 1.07. What is the ratio of the CO2 emissions (% of total fuel combustion) of High income: OECD in 2010 to that in 2012?
Make the answer very short. 1.06. What is the ratio of the CO2 emissions (% of total fuel combustion) of Congo (Republic) in 2010 to that in 2012?
Give a very brief answer. 1.02. What is the ratio of the CO2 emissions (% of total fuel combustion) of Turkmenistan in 2010 to that in 2012?
Your answer should be compact. 1.02. What is the ratio of the CO2 emissions (% of total fuel combustion) in Europe(all income levels) in 2011 to that in 2012?
Ensure brevity in your answer.  0.99. What is the ratio of the CO2 emissions (% of total fuel combustion) in High income: OECD in 2011 to that in 2012?
Make the answer very short. 1. What is the ratio of the CO2 emissions (% of total fuel combustion) of Congo (Republic) in 2011 to that in 2012?
Keep it short and to the point. 0.81. What is the ratio of the CO2 emissions (% of total fuel combustion) of Turkmenistan in 2011 to that in 2012?
Your response must be concise. 1. What is the difference between the highest and the second highest CO2 emissions (% of total fuel combustion) in Europe(all income levels)?
Offer a very short reply. 0.07. What is the difference between the highest and the second highest CO2 emissions (% of total fuel combustion) of High income: OECD?
Offer a terse response. 0.2. What is the difference between the highest and the second highest CO2 emissions (% of total fuel combustion) in Congo (Republic)?
Your answer should be very brief. 0.07. What is the difference between the highest and the second highest CO2 emissions (% of total fuel combustion) in Turkmenistan?
Offer a terse response. 0.13. What is the difference between the highest and the lowest CO2 emissions (% of total fuel combustion) of Europe(all income levels)?
Keep it short and to the point. 1.67. What is the difference between the highest and the lowest CO2 emissions (% of total fuel combustion) in High income: OECD?
Keep it short and to the point. 1.22. What is the difference between the highest and the lowest CO2 emissions (% of total fuel combustion) in Congo (Republic)?
Keep it short and to the point. 1.75. What is the difference between the highest and the lowest CO2 emissions (% of total fuel combustion) of Turkmenistan?
Your answer should be compact. 3. 